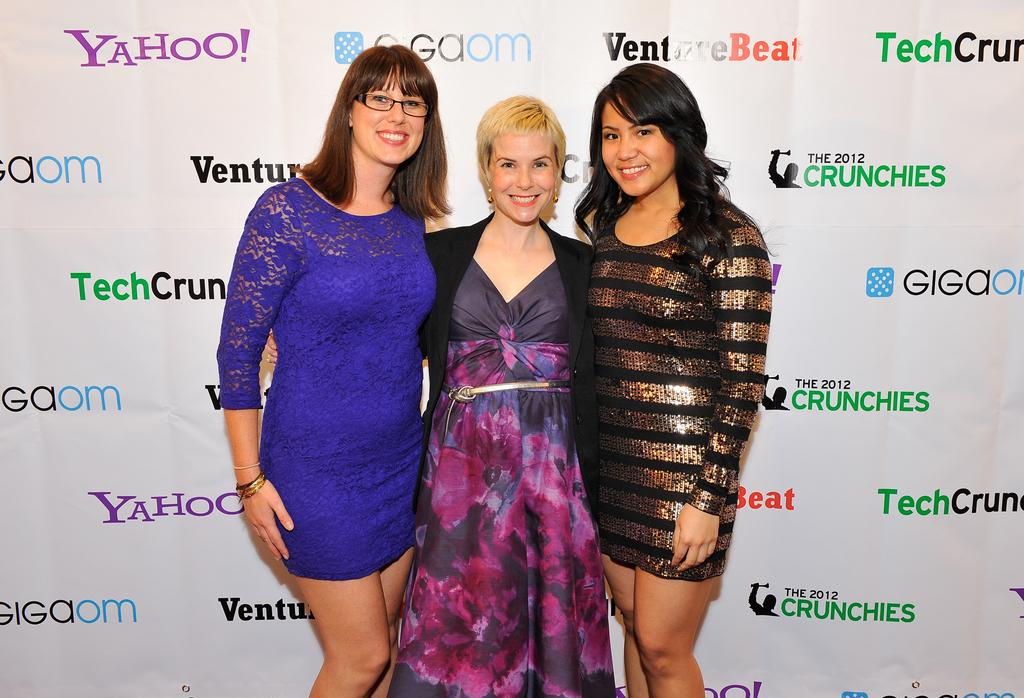How many people are in the image? There are persons in the image, but the exact number is not specified. What are the persons wearing? The persons are wearing clothes. What can be seen behind the persons in the image? The persons are standing in front of a sponsor board. What type of hole can be seen in the image? There is no hole present in the image. 